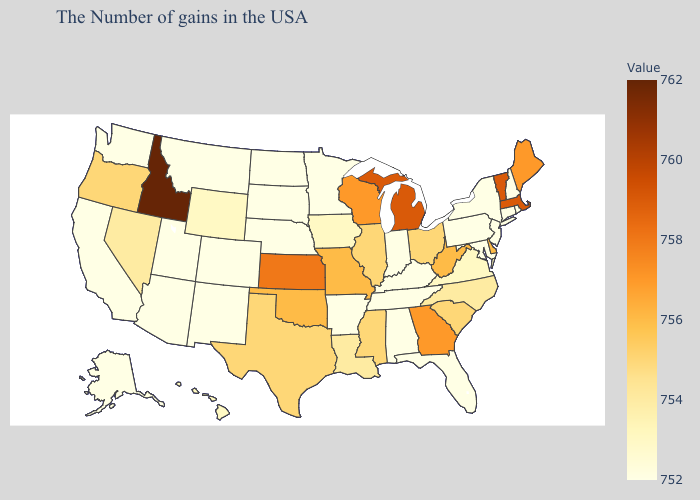Does Idaho have the highest value in the USA?
Give a very brief answer. Yes. Does Michigan have a higher value than Idaho?
Keep it brief. No. Does Minnesota have the lowest value in the USA?
Short answer required. Yes. Does Colorado have the lowest value in the West?
Concise answer only. Yes. Does the map have missing data?
Quick response, please. No. Among the states that border Nevada , which have the highest value?
Write a very short answer. Idaho. 